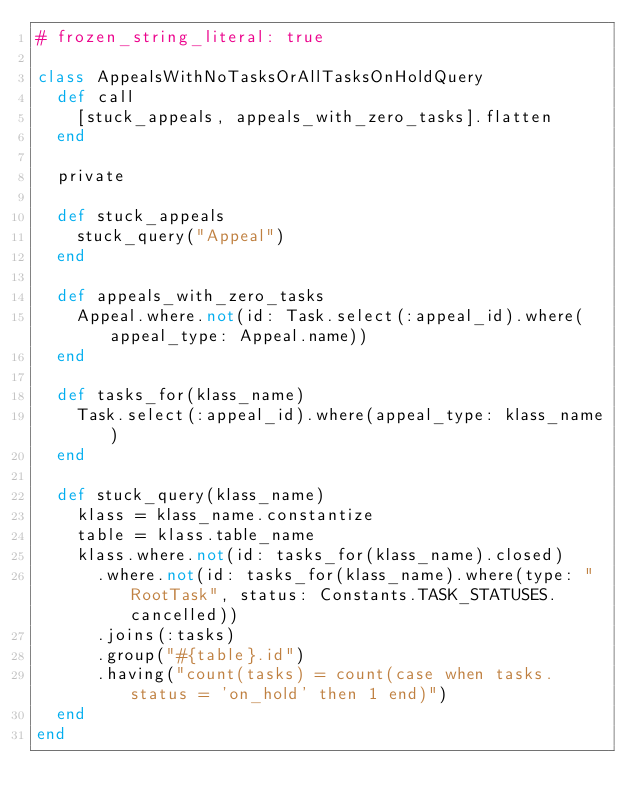Convert code to text. <code><loc_0><loc_0><loc_500><loc_500><_Ruby_># frozen_string_literal: true

class AppealsWithNoTasksOrAllTasksOnHoldQuery
  def call
    [stuck_appeals, appeals_with_zero_tasks].flatten
  end

  private

  def stuck_appeals
    stuck_query("Appeal")
  end

  def appeals_with_zero_tasks
    Appeal.where.not(id: Task.select(:appeal_id).where(appeal_type: Appeal.name))
  end

  def tasks_for(klass_name)
    Task.select(:appeal_id).where(appeal_type: klass_name)
  end

  def stuck_query(klass_name)
    klass = klass_name.constantize
    table = klass.table_name
    klass.where.not(id: tasks_for(klass_name).closed)
      .where.not(id: tasks_for(klass_name).where(type: "RootTask", status: Constants.TASK_STATUSES.cancelled))
      .joins(:tasks)
      .group("#{table}.id")
      .having("count(tasks) = count(case when tasks.status = 'on_hold' then 1 end)")
  end
end
</code> 